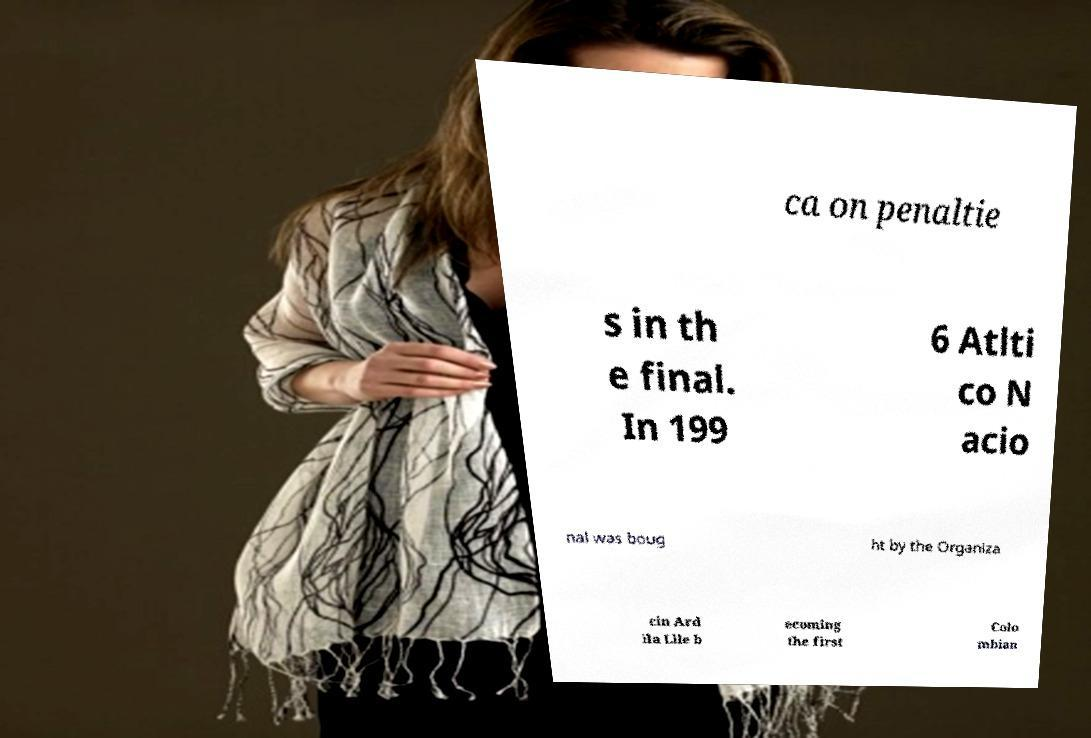Please read and relay the text visible in this image. What does it say? ca on penaltie s in th e final. In 199 6 Atlti co N acio nal was boug ht by the Organiza cin Ard ila Llle b ecoming the first Colo mbian 